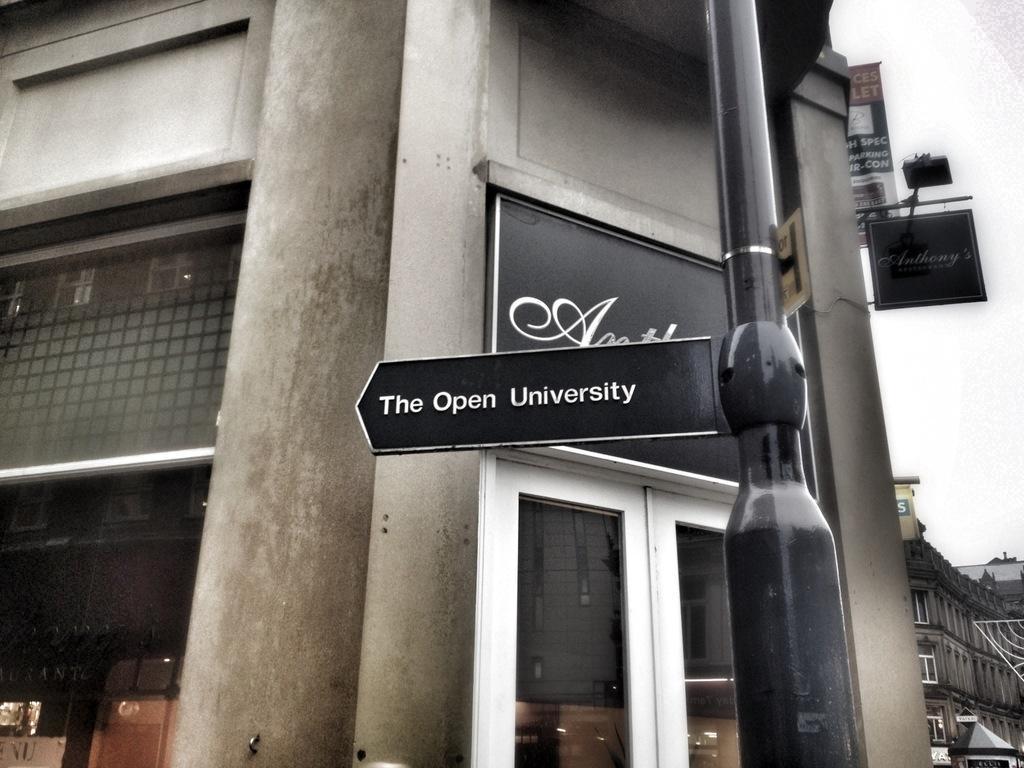In one or two sentences, can you explain what this image depicts? In front of the picture, we see a black color board. We see a board in black color with text written as "The Open university". Beside that, we see a pole. Behind that, we see a building in grey color. It has the windows and the glass door. In the middle, we see a board in black color with some text written. On the left side, we see the objects in brown color. On the right side, we see a board in black color with some text written. Beside that, we see a banner. In the right bottom, we see the buildings. 